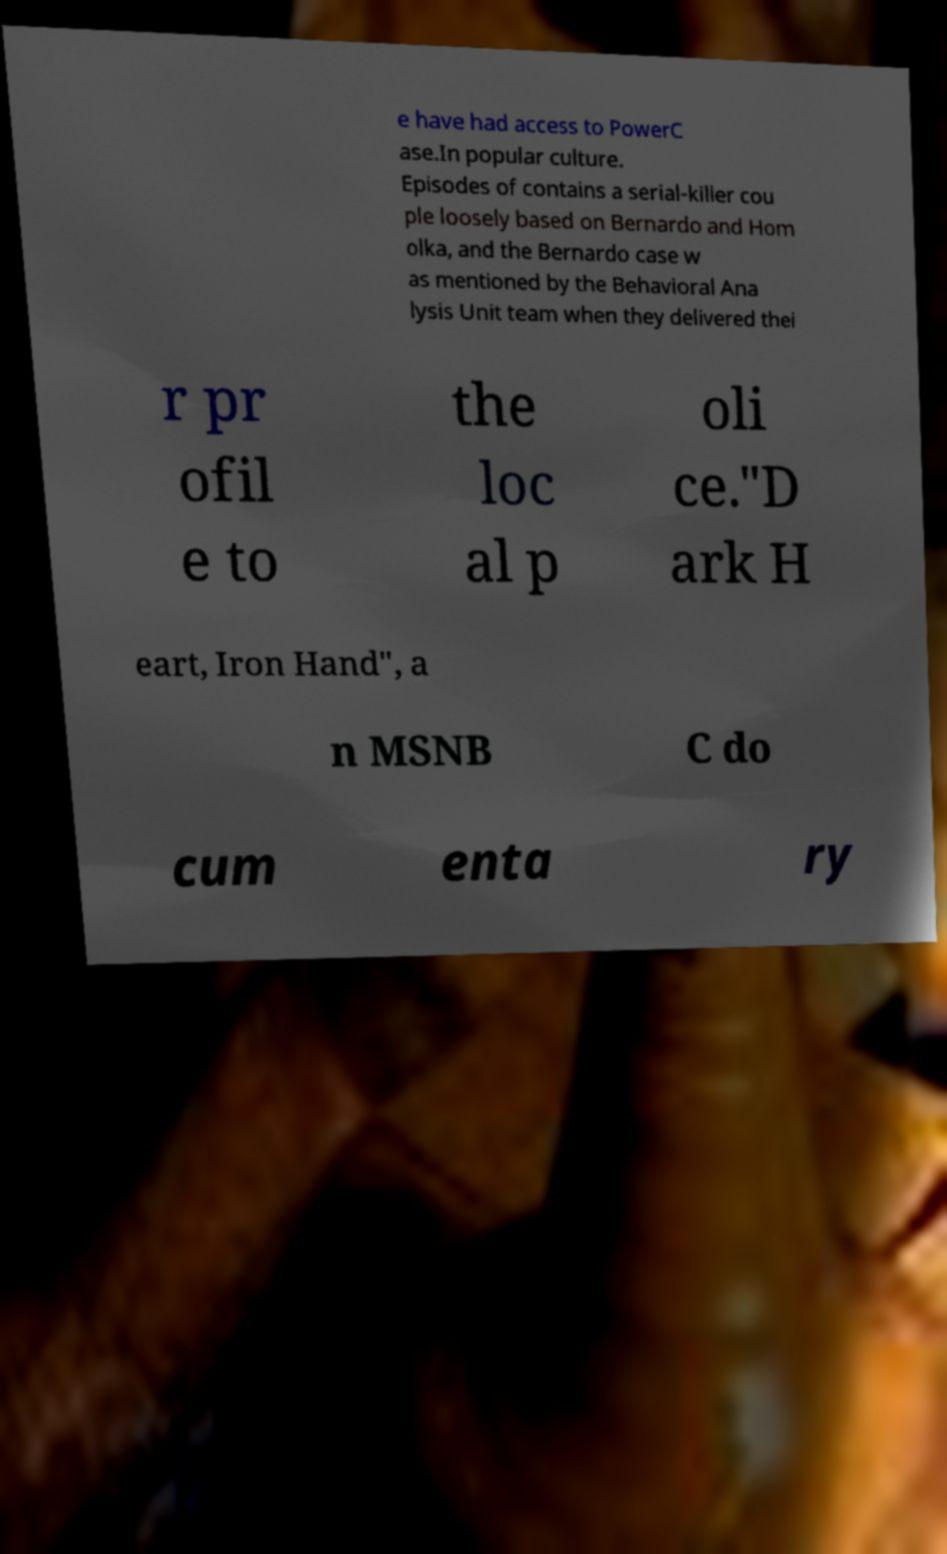There's text embedded in this image that I need extracted. Can you transcribe it verbatim? e have had access to PowerC ase.In popular culture. Episodes of contains a serial-killer cou ple loosely based on Bernardo and Hom olka, and the Bernardo case w as mentioned by the Behavioral Ana lysis Unit team when they delivered thei r pr ofil e to the loc al p oli ce."D ark H eart, Iron Hand", a n MSNB C do cum enta ry 